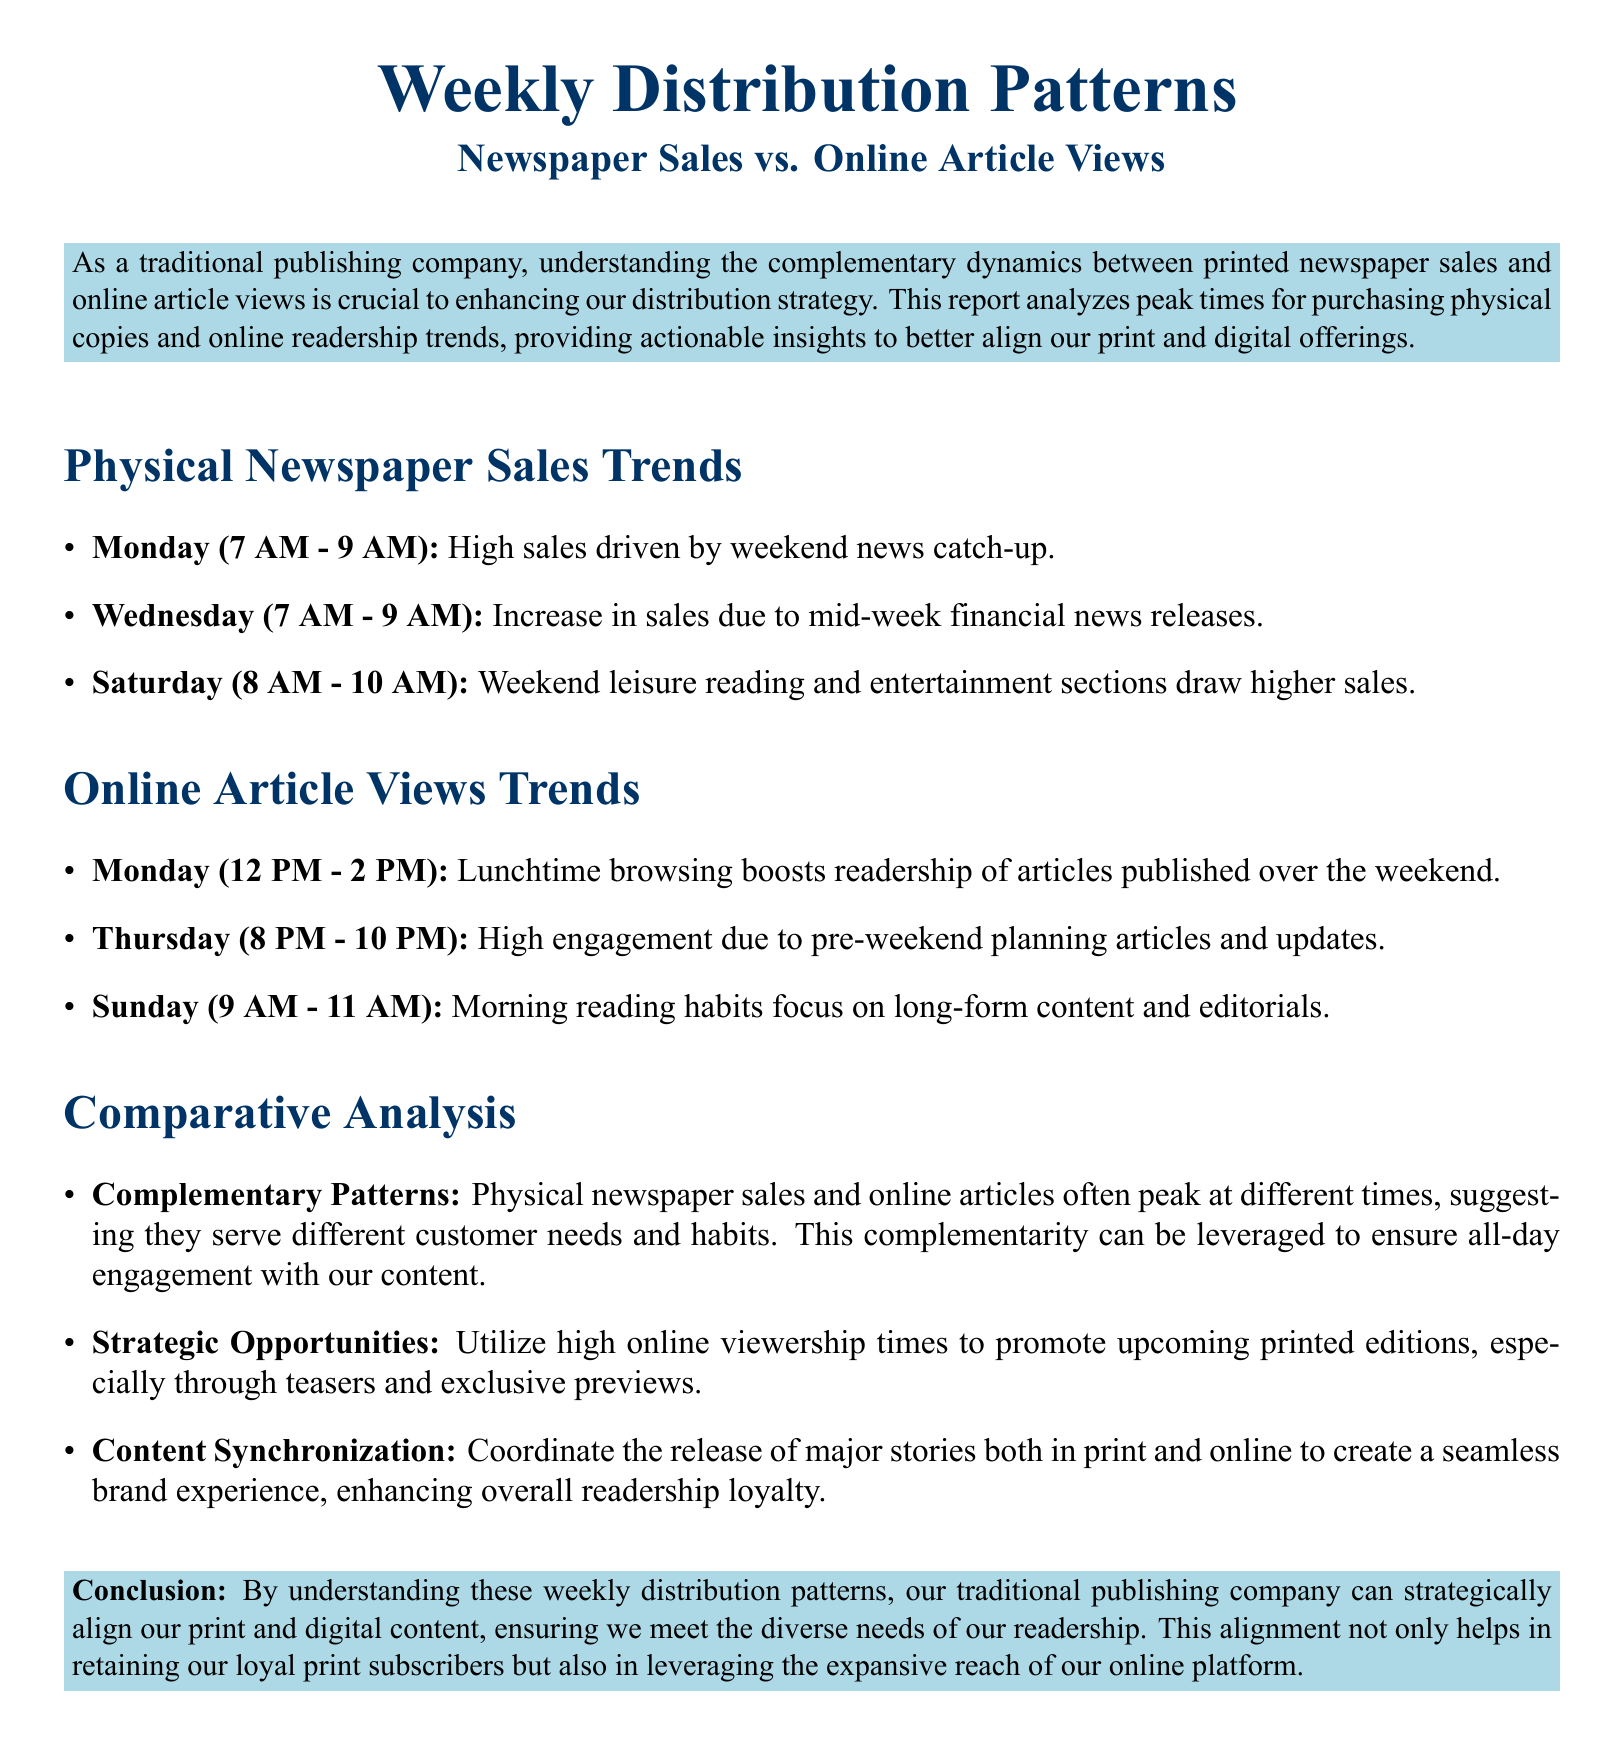what time are high newspaper sales on Monday? High newspaper sales on Monday occur from 7 AM to 9 AM, driven by weekend news catch-up.
Answer: 7 AM - 9 AM which day shows increased newspaper sales due to mid-week financial news releases? The day with increased newspaper sales due to mid-week financial news releases is Wednesday.
Answer: Wednesday what time peak online article views occur on Thursday? Peak online article views on Thursday occur from 8 PM to 10 PM, due to pre-weekend planning articles and updates.
Answer: 8 PM - 10 PM what is a key complementary pattern identified in the report? A key complementary pattern identified is that physical newspaper sales and online articles often peak at different times, serving different customer needs.
Answer: Different times what is the recommended strategy during high online viewership times? The recommended strategy during high online viewership times is to promote upcoming printed editions through teasers and exclusive previews.
Answer: Promote printed editions what time do online article views peak on Sunday? Online article views peak on Sunday from 9 AM to 11 AM, focusing on long-form content and editorials.
Answer: 9 AM - 11 AM which section of the document discusses strategic opportunities? The section that discusses strategic opportunities is the Comparative Analysis.
Answer: Comparative Analysis what is the main purpose of understanding weekly distribution patterns according to the report? The main purpose is to strategically align print and digital content to meet diverse readership needs.
Answer: Align print and digital content 